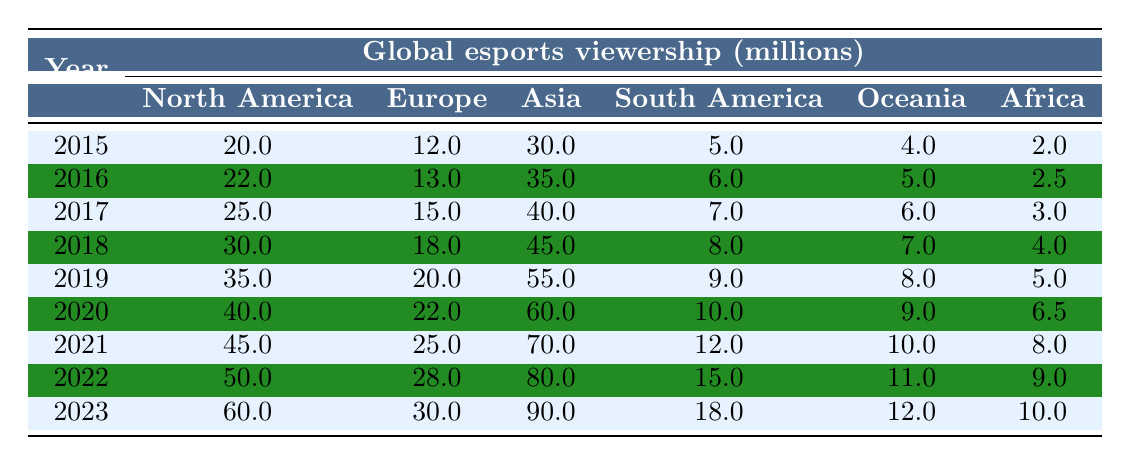What was the viewership in Asia in 2020? According to the table, Asia's viewership in 2020 is listed as 60 million.
Answer: 60 million Which region had the highest esports viewership in 2022? From the table, Asia had the highest viewership in 2022, with 80 million.
Answer: Asia How much did the esports viewership in South America increase from 2015 to 2023? The viewership in South America increased from 5 million in 2015 to 18 million in 2023. The increase is calculated as 18 million - 5 million = 13 million.
Answer: 13 million What is the average viewership in North America over the years from 2015 to 2023? North America's viewership values are 20, 22, 25, 30, 35, 40, 45, 50, and 60 million. Summing these values gives 20 + 22 + 25 + 30 + 35 + 40 + 45 + 50 + 60 = 327 million. There are 9 data points, so the average is 327 million / 9 = 36.33 million.
Answer: 36.33 million Did Africa's esports viewership ever exceed 8 million between 2015 and 2023? Looking at the table, Africa's viewership peaked at 10 million in 2023, which means it did exceed 8 million during that time period.
Answer: Yes Which region experienced the smallest increase in viewership from 2015 to 2023? By examining the incremental changes from the table, Africa's viewership increased from 2 million in 2015 to 10 million in 2023, an increase of 8 million. The other regions had larger increases: North America (40 million), Europe (18 million), Asia (60 million), South America (13 million), and Oceania (8 million). Therefore, Africa had the smallest increase.
Answer: Africa Which years saw viewership in Europe surpass 25 million? Reviewing the data in the table, Europe exceeded 25 million in 2021, 2022, and 2023, where values were 25 million, 28 million, and 30 million respectively.
Answer: 2021, 2022, 2023 What percentage of the total global esports viewership did Asia represent in 2023? In 2023, the total global viewership across all regions is 60000000 (North America) + 30000000 (Europe) + 90000000 (Asia) + 18000000 (South America) + 12000000 (Oceania) + 10000000 (Africa) = 230 million. Asia's viewership in 2023 is 90 million. The percentage is (90 million / 230 million) * 100 ≈ 39.13%.
Answer: 39.13% What was the total viewership for all regions combined in 2019? The total viewership for 2019 can be calculated by adding the values for that year: 35 million (North America) + 20 million (Europe) + 55 million (Asia) + 9 million (South America) + 8 million (Oceania) + 5 million (Africa) = 132 million.
Answer: 132 million How does the growth rate in viewership from 2022 to 2023 compare with the growth rate from 2015 to 2016? The growth from 2022 (50 million) to 2023 (60 million) is an increase of 10 million (20% growth rate). The growth from 2015 (20 million) to 2016 (22 million) is an increase of 2 million (10% growth rate). Comparing both growth rates, the 2022 to 2023 rate of 20% is larger than the 2015 to 2016 rate of 10%.
Answer: 20% is larger than 10% 